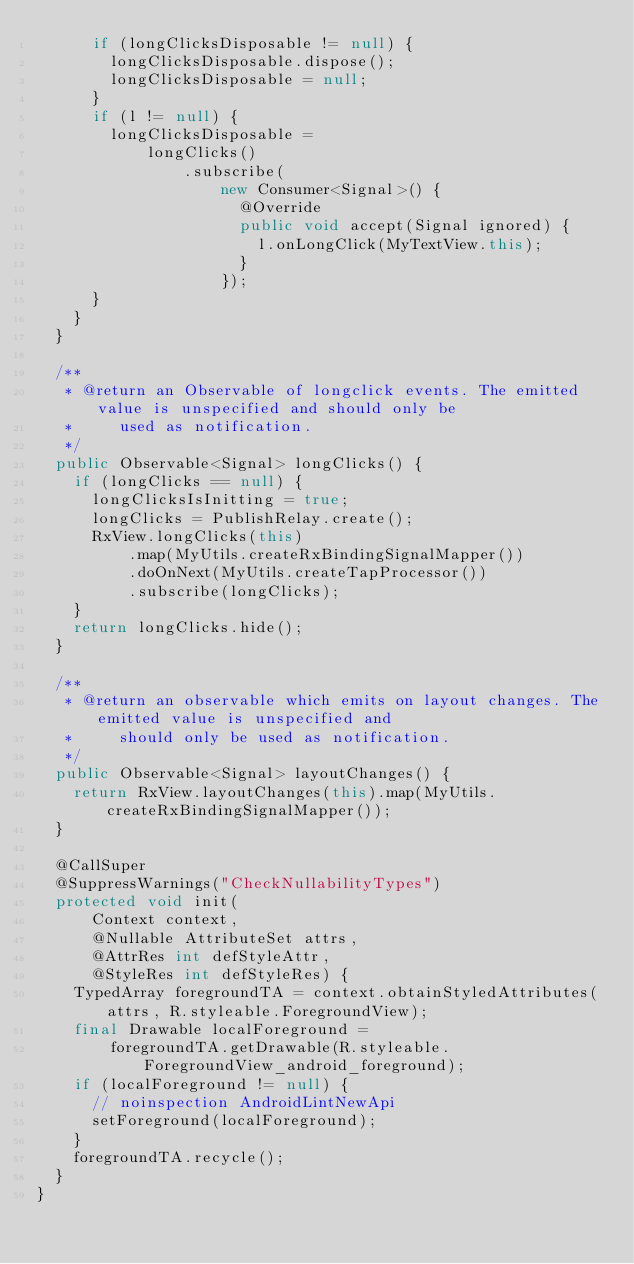<code> <loc_0><loc_0><loc_500><loc_500><_Java_>      if (longClicksDisposable != null) {
        longClicksDisposable.dispose();
        longClicksDisposable = null;
      }
      if (l != null) {
        longClicksDisposable =
            longClicks()
                .subscribe(
                    new Consumer<Signal>() {
                      @Override
                      public void accept(Signal ignored) {
                        l.onLongClick(MyTextView.this);
                      }
                    });
      }
    }
  }

  /**
   * @return an Observable of longclick events. The emitted value is unspecified and should only be
   *     used as notification.
   */
  public Observable<Signal> longClicks() {
    if (longClicks == null) {
      longClicksIsInitting = true;
      longClicks = PublishRelay.create();
      RxView.longClicks(this)
          .map(MyUtils.createRxBindingSignalMapper())
          .doOnNext(MyUtils.createTapProcessor())
          .subscribe(longClicks);
    }
    return longClicks.hide();
  }

  /**
   * @return an observable which emits on layout changes. The emitted value is unspecified and
   *     should only be used as notification.
   */
  public Observable<Signal> layoutChanges() {
    return RxView.layoutChanges(this).map(MyUtils.createRxBindingSignalMapper());
  }

  @CallSuper
  @SuppressWarnings("CheckNullabilityTypes")
  protected void init(
      Context context,
      @Nullable AttributeSet attrs,
      @AttrRes int defStyleAttr,
      @StyleRes int defStyleRes) {
    TypedArray foregroundTA = context.obtainStyledAttributes(attrs, R.styleable.ForegroundView);
    final Drawable localForeground =
        foregroundTA.getDrawable(R.styleable.ForegroundView_android_foreground);
    if (localForeground != null) {
      // noinspection AndroidLintNewApi
      setForeground(localForeground);
    }
    foregroundTA.recycle();
  }
}
</code> 